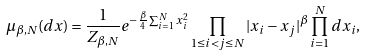<formula> <loc_0><loc_0><loc_500><loc_500>\mu _ { \beta , N } ( d x ) = \frac { 1 } { Z _ { \beta , N } } e ^ { - \frac { \beta } { 4 } \sum _ { i = 1 } ^ { N } x _ { i } ^ { 2 } } \prod _ { 1 \leq i < j \leq N } | x _ { i } - x _ { j } | ^ { \beta } \prod _ { i = 1 } ^ { N } d x _ { i } ,</formula> 